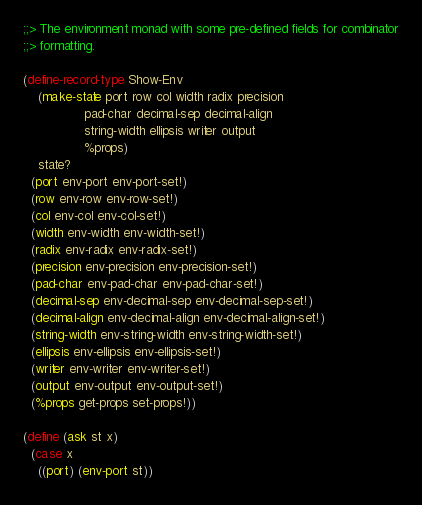Convert code to text. <code><loc_0><loc_0><loc_500><loc_500><_Scheme_>;;> The environment monad with some pre-defined fields for combinator
;;> formatting.

(define-record-type Show-Env
    (make-state port row col width radix precision
                pad-char decimal-sep decimal-align
                string-width ellipsis writer output
                %props)
    state?
  (port env-port env-port-set!)
  (row env-row env-row-set!)
  (col env-col env-col-set!)
  (width env-width env-width-set!)
  (radix env-radix env-radix-set!)
  (precision env-precision env-precision-set!)
  (pad-char env-pad-char env-pad-char-set!)
  (decimal-sep env-decimal-sep env-decimal-sep-set!)
  (decimal-align env-decimal-align env-decimal-align-set!)
  (string-width env-string-width env-string-width-set!)
  (ellipsis env-ellipsis env-ellipsis-set!)
  (writer env-writer env-writer-set!)
  (output env-output env-output-set!)
  (%props get-props set-props!))

(define (ask st x)
  (case x
    ((port) (env-port st))</code> 